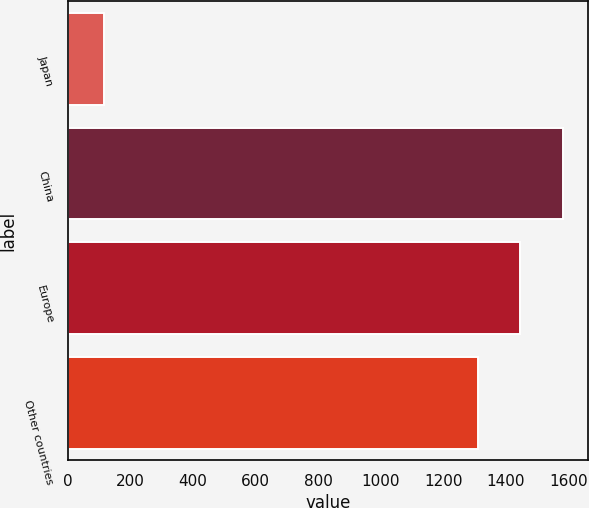Convert chart. <chart><loc_0><loc_0><loc_500><loc_500><bar_chart><fcel>Japan<fcel>China<fcel>Europe<fcel>Other countries<nl><fcel>116<fcel>1583.4<fcel>1447.2<fcel>1311<nl></chart> 